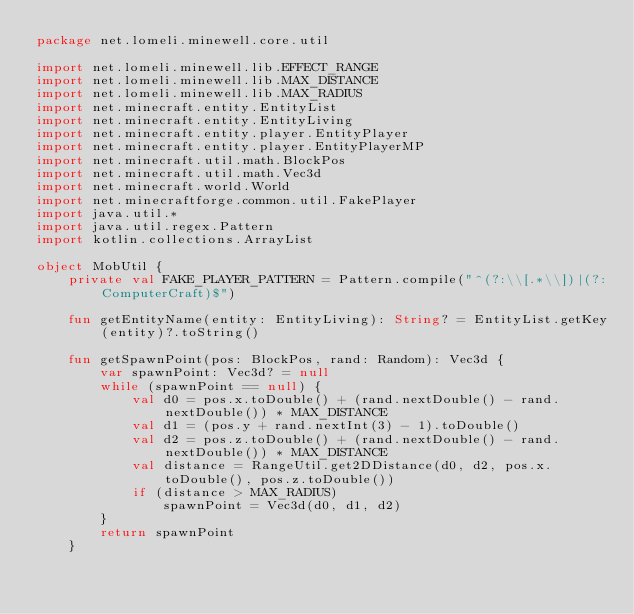Convert code to text. <code><loc_0><loc_0><loc_500><loc_500><_Kotlin_>package net.lomeli.minewell.core.util

import net.lomeli.minewell.lib.EFFECT_RANGE
import net.lomeli.minewell.lib.MAX_DISTANCE
import net.lomeli.minewell.lib.MAX_RADIUS
import net.minecraft.entity.EntityList
import net.minecraft.entity.EntityLiving
import net.minecraft.entity.player.EntityPlayer
import net.minecraft.entity.player.EntityPlayerMP
import net.minecraft.util.math.BlockPos
import net.minecraft.util.math.Vec3d
import net.minecraft.world.World
import net.minecraftforge.common.util.FakePlayer
import java.util.*
import java.util.regex.Pattern
import kotlin.collections.ArrayList

object MobUtil {
    private val FAKE_PLAYER_PATTERN = Pattern.compile("^(?:\\[.*\\])|(?:ComputerCraft)$")

    fun getEntityName(entity: EntityLiving): String? = EntityList.getKey(entity)?.toString()

    fun getSpawnPoint(pos: BlockPos, rand: Random): Vec3d {
        var spawnPoint: Vec3d? = null
        while (spawnPoint == null) {
            val d0 = pos.x.toDouble() + (rand.nextDouble() - rand.nextDouble()) * MAX_DISTANCE
            val d1 = (pos.y + rand.nextInt(3) - 1).toDouble()
            val d2 = pos.z.toDouble() + (rand.nextDouble() - rand.nextDouble()) * MAX_DISTANCE
            val distance = RangeUtil.get2DDistance(d0, d2, pos.x.toDouble(), pos.z.toDouble())
            if (distance > MAX_RADIUS)
                spawnPoint = Vec3d(d0, d1, d2)
        }
        return spawnPoint
    }
</code> 